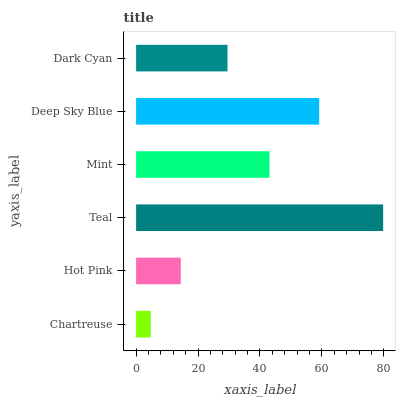Is Chartreuse the minimum?
Answer yes or no. Yes. Is Teal the maximum?
Answer yes or no. Yes. Is Hot Pink the minimum?
Answer yes or no. No. Is Hot Pink the maximum?
Answer yes or no. No. Is Hot Pink greater than Chartreuse?
Answer yes or no. Yes. Is Chartreuse less than Hot Pink?
Answer yes or no. Yes. Is Chartreuse greater than Hot Pink?
Answer yes or no. No. Is Hot Pink less than Chartreuse?
Answer yes or no. No. Is Mint the high median?
Answer yes or no. Yes. Is Dark Cyan the low median?
Answer yes or no. Yes. Is Hot Pink the high median?
Answer yes or no. No. Is Mint the low median?
Answer yes or no. No. 